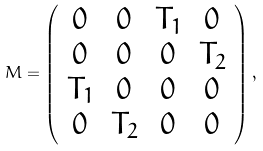Convert formula to latex. <formula><loc_0><loc_0><loc_500><loc_500>M = \left ( \begin{array} { c c c c } 0 & 0 & T _ { 1 } & 0 \\ 0 & 0 & 0 & T _ { 2 } \\ T _ { 1 } & 0 & 0 & 0 \\ 0 & T _ { 2 } & 0 & 0 \\ \end{array} \right ) ,</formula> 